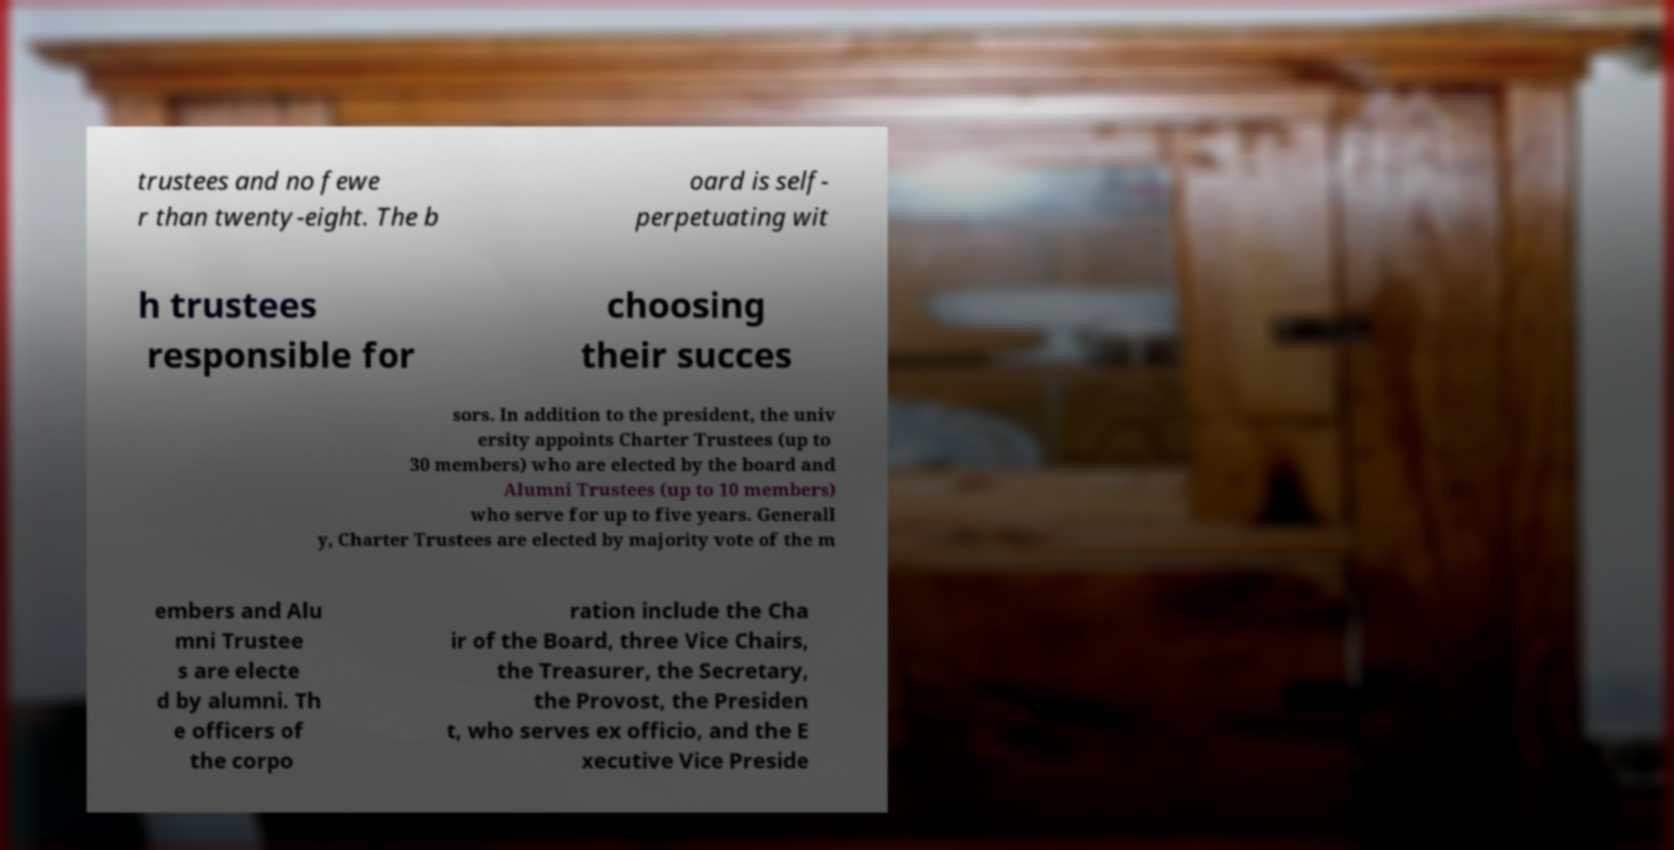Could you extract and type out the text from this image? trustees and no fewe r than twenty-eight. The b oard is self- perpetuating wit h trustees responsible for choosing their succes sors. In addition to the president, the univ ersity appoints Charter Trustees (up to 30 members) who are elected by the board and Alumni Trustees (up to 10 members) who serve for up to five years. Generall y, Charter Trustees are elected by majority vote of the m embers and Alu mni Trustee s are electe d by alumni. Th e officers of the corpo ration include the Cha ir of the Board, three Vice Chairs, the Treasurer, the Secretary, the Provost, the Presiden t, who serves ex officio, and the E xecutive Vice Preside 